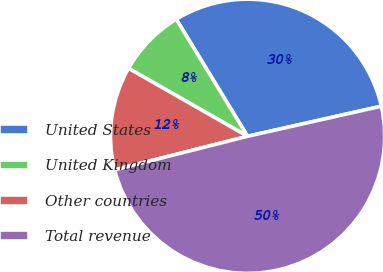<chart> <loc_0><loc_0><loc_500><loc_500><pie_chart><fcel>United States<fcel>United Kingdom<fcel>Other countries<fcel>Total revenue<nl><fcel>30.19%<fcel>8.03%<fcel>12.19%<fcel>49.58%<nl></chart> 